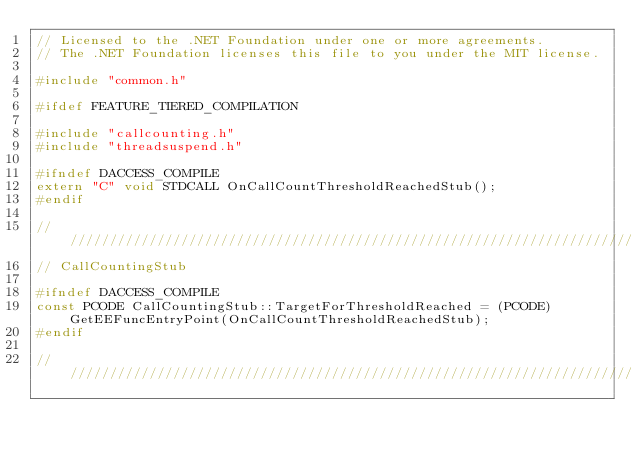Convert code to text. <code><loc_0><loc_0><loc_500><loc_500><_C++_>// Licensed to the .NET Foundation under one or more agreements.
// The .NET Foundation licenses this file to you under the MIT license.

#include "common.h"

#ifdef FEATURE_TIERED_COMPILATION

#include "callcounting.h"
#include "threadsuspend.h"

#ifndef DACCESS_COMPILE
extern "C" void STDCALL OnCallCountThresholdReachedStub();
#endif

////////////////////////////////////////////////////////////////////////////////////////////////////////////////////////////////
// CallCountingStub

#ifndef DACCESS_COMPILE
const PCODE CallCountingStub::TargetForThresholdReached = (PCODE)GetEEFuncEntryPoint(OnCallCountThresholdReachedStub);
#endif

////////////////////////////////////////////////////////////////////////////////////////////////////////////////////////////////</code> 